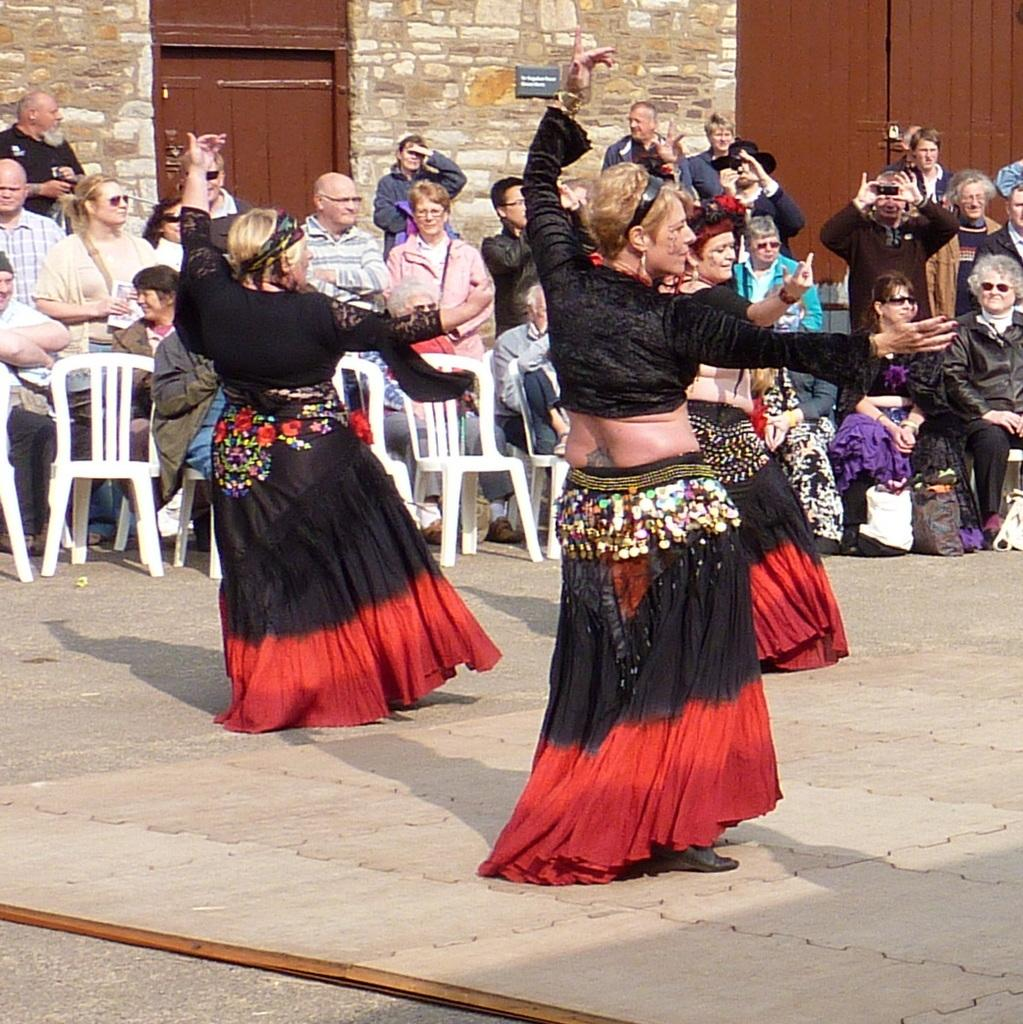What are the women in the image doing? The three women in the image are dancing. What are other people in the image doing? There are people standing and sitting on chairs in the image. What can be seen in the background of the image? There is a wall and wooden doors in the background of the image. What type of skate is being used by the women in the image? There is no skate present in the image; the women are dancing. Can you tell me how many volleyballs are visible in the image? There are no volleyballs present in the image. 